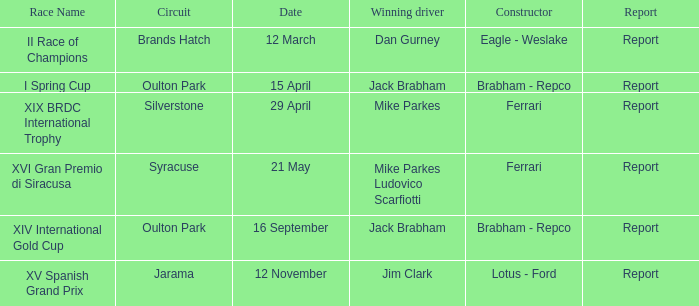What is the circuit held on 15 april? Oulton Park. 